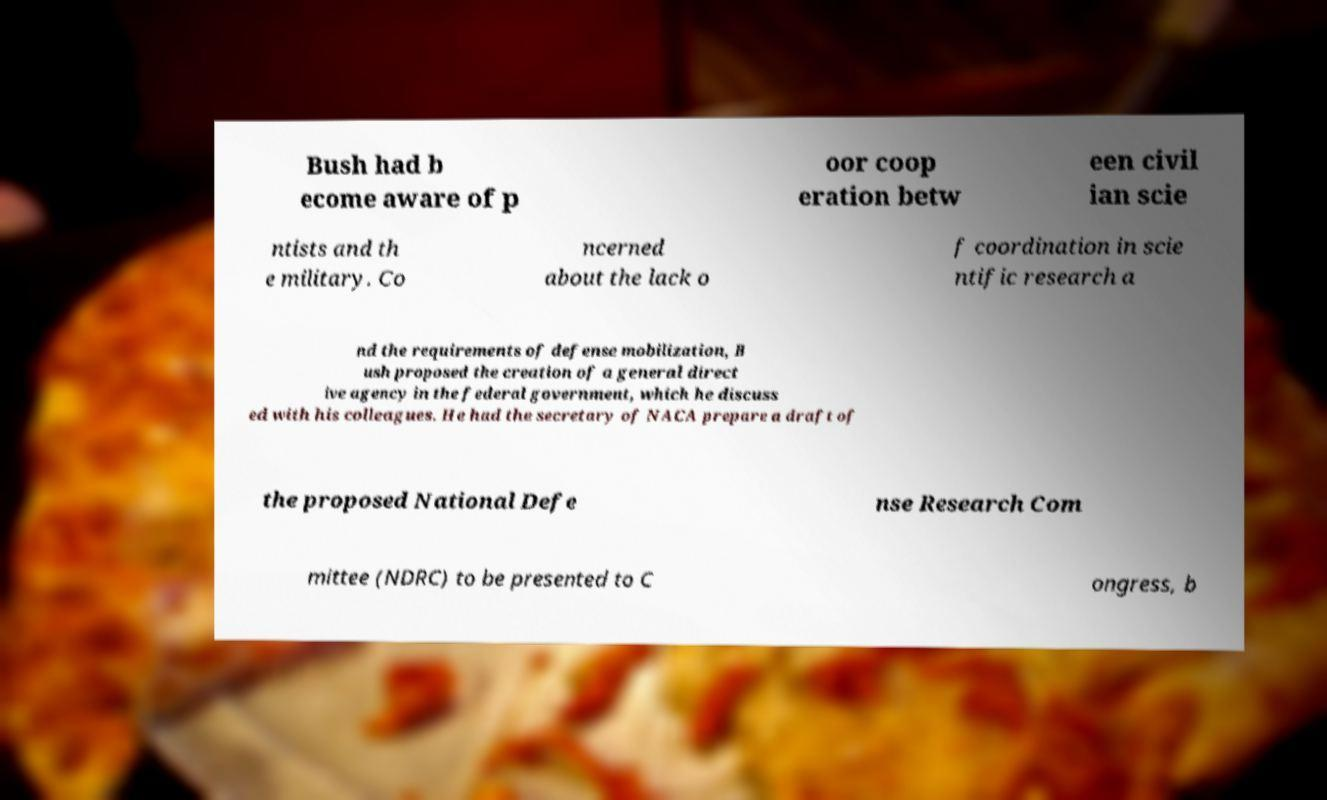Please identify and transcribe the text found in this image. Bush had b ecome aware of p oor coop eration betw een civil ian scie ntists and th e military. Co ncerned about the lack o f coordination in scie ntific research a nd the requirements of defense mobilization, B ush proposed the creation of a general direct ive agency in the federal government, which he discuss ed with his colleagues. He had the secretary of NACA prepare a draft of the proposed National Defe nse Research Com mittee (NDRC) to be presented to C ongress, b 